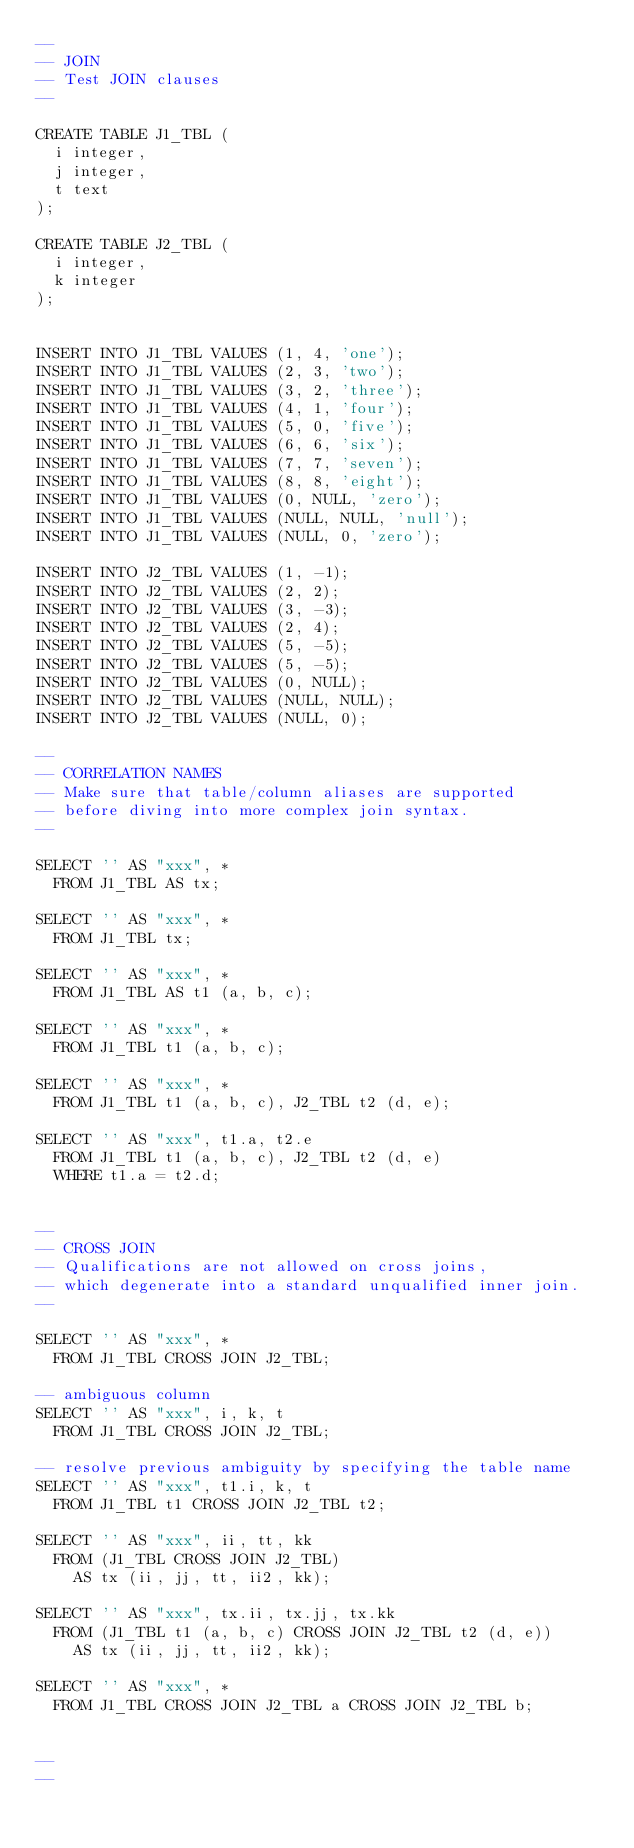<code> <loc_0><loc_0><loc_500><loc_500><_SQL_>--
-- JOIN
-- Test JOIN clauses
--

CREATE TABLE J1_TBL (
  i integer,
  j integer,
  t text
);

CREATE TABLE J2_TBL (
  i integer,
  k integer
);


INSERT INTO J1_TBL VALUES (1, 4, 'one');
INSERT INTO J1_TBL VALUES (2, 3, 'two');
INSERT INTO J1_TBL VALUES (3, 2, 'three');
INSERT INTO J1_TBL VALUES (4, 1, 'four');
INSERT INTO J1_TBL VALUES (5, 0, 'five');
INSERT INTO J1_TBL VALUES (6, 6, 'six');
INSERT INTO J1_TBL VALUES (7, 7, 'seven');
INSERT INTO J1_TBL VALUES (8, 8, 'eight');
INSERT INTO J1_TBL VALUES (0, NULL, 'zero');
INSERT INTO J1_TBL VALUES (NULL, NULL, 'null');
INSERT INTO J1_TBL VALUES (NULL, 0, 'zero');

INSERT INTO J2_TBL VALUES (1, -1);
INSERT INTO J2_TBL VALUES (2, 2);
INSERT INTO J2_TBL VALUES (3, -3);
INSERT INTO J2_TBL VALUES (2, 4);
INSERT INTO J2_TBL VALUES (5, -5);
INSERT INTO J2_TBL VALUES (5, -5);
INSERT INTO J2_TBL VALUES (0, NULL);
INSERT INTO J2_TBL VALUES (NULL, NULL);
INSERT INTO J2_TBL VALUES (NULL, 0);

--
-- CORRELATION NAMES
-- Make sure that table/column aliases are supported
-- before diving into more complex join syntax.
--

SELECT '' AS "xxx", *
  FROM J1_TBL AS tx;

SELECT '' AS "xxx", *
  FROM J1_TBL tx;

SELECT '' AS "xxx", *
  FROM J1_TBL AS t1 (a, b, c);

SELECT '' AS "xxx", *
  FROM J1_TBL t1 (a, b, c);

SELECT '' AS "xxx", *
  FROM J1_TBL t1 (a, b, c), J2_TBL t2 (d, e);

SELECT '' AS "xxx", t1.a, t2.e
  FROM J1_TBL t1 (a, b, c), J2_TBL t2 (d, e)
  WHERE t1.a = t2.d;


--
-- CROSS JOIN
-- Qualifications are not allowed on cross joins,
-- which degenerate into a standard unqualified inner join.
--

SELECT '' AS "xxx", *
  FROM J1_TBL CROSS JOIN J2_TBL;

-- ambiguous column
SELECT '' AS "xxx", i, k, t
  FROM J1_TBL CROSS JOIN J2_TBL;

-- resolve previous ambiguity by specifying the table name
SELECT '' AS "xxx", t1.i, k, t
  FROM J1_TBL t1 CROSS JOIN J2_TBL t2;

SELECT '' AS "xxx", ii, tt, kk
  FROM (J1_TBL CROSS JOIN J2_TBL)
    AS tx (ii, jj, tt, ii2, kk);

SELECT '' AS "xxx", tx.ii, tx.jj, tx.kk
  FROM (J1_TBL t1 (a, b, c) CROSS JOIN J2_TBL t2 (d, e))
    AS tx (ii, jj, tt, ii2, kk);

SELECT '' AS "xxx", *
  FROM J1_TBL CROSS JOIN J2_TBL a CROSS JOIN J2_TBL b;


--
--</code> 